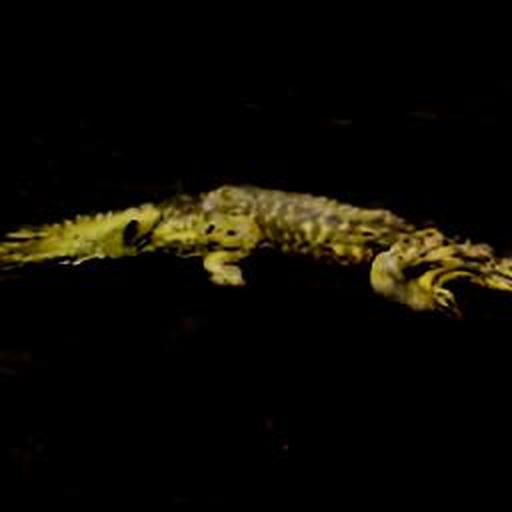Can you describe the animal in this photograph? The animal in the photograph seems to be a crocodile, distinguishable by its elongated snout, robust body, and visible scales. Due to the image's low lighting, specific patterns or coloration are difficult to discern. 